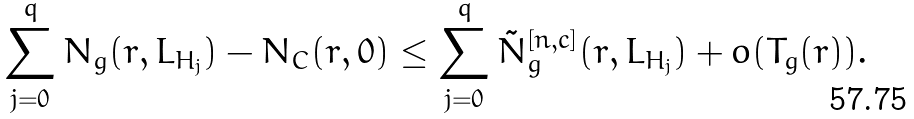Convert formula to latex. <formula><loc_0><loc_0><loc_500><loc_500>\sum _ { j = 0 } ^ { q } N _ { g } ( r , L _ { H _ { j } } ) - N _ { C } ( r , 0 ) \leq \sum _ { j = 0 } ^ { q } \tilde { N } _ { g } ^ { [ n , c ] } ( r , L _ { H _ { j } } ) + o ( T _ { g } ( r ) ) .</formula> 